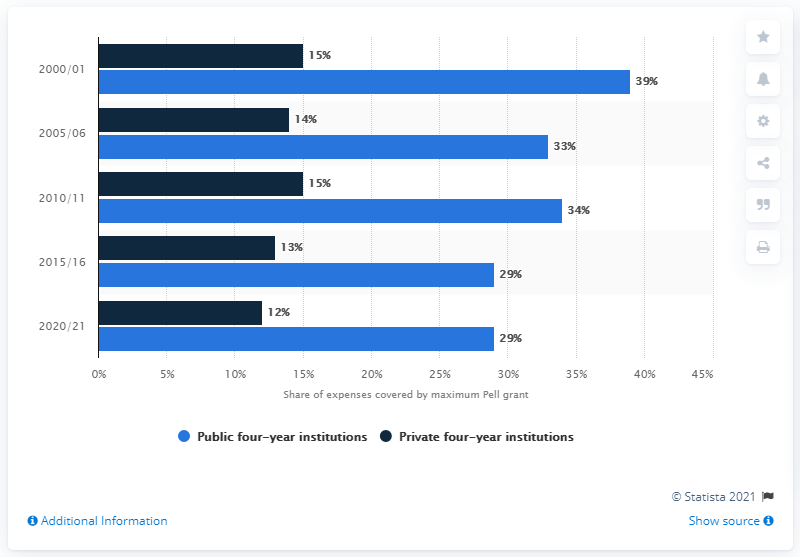Identify some key points in this picture. In 2020/2021, 29% of students' expenses were covered by the federal Pell grant program. 